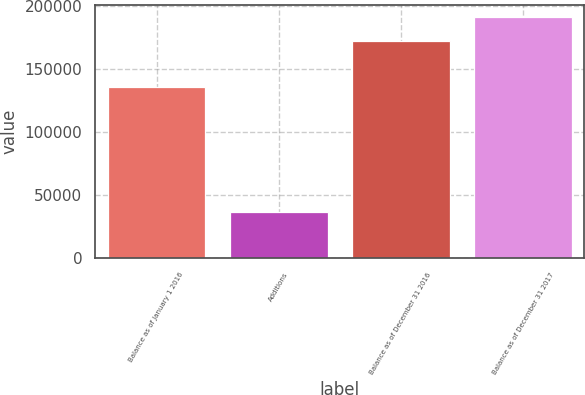Convert chart to OTSL. <chart><loc_0><loc_0><loc_500><loc_500><bar_chart><fcel>Balance as of January 1 2016<fcel>Additions<fcel>Balance as of December 31 2016<fcel>Balance as of December 31 2017<nl><fcel>136079<fcel>36267<fcel>172593<fcel>191091<nl></chart> 